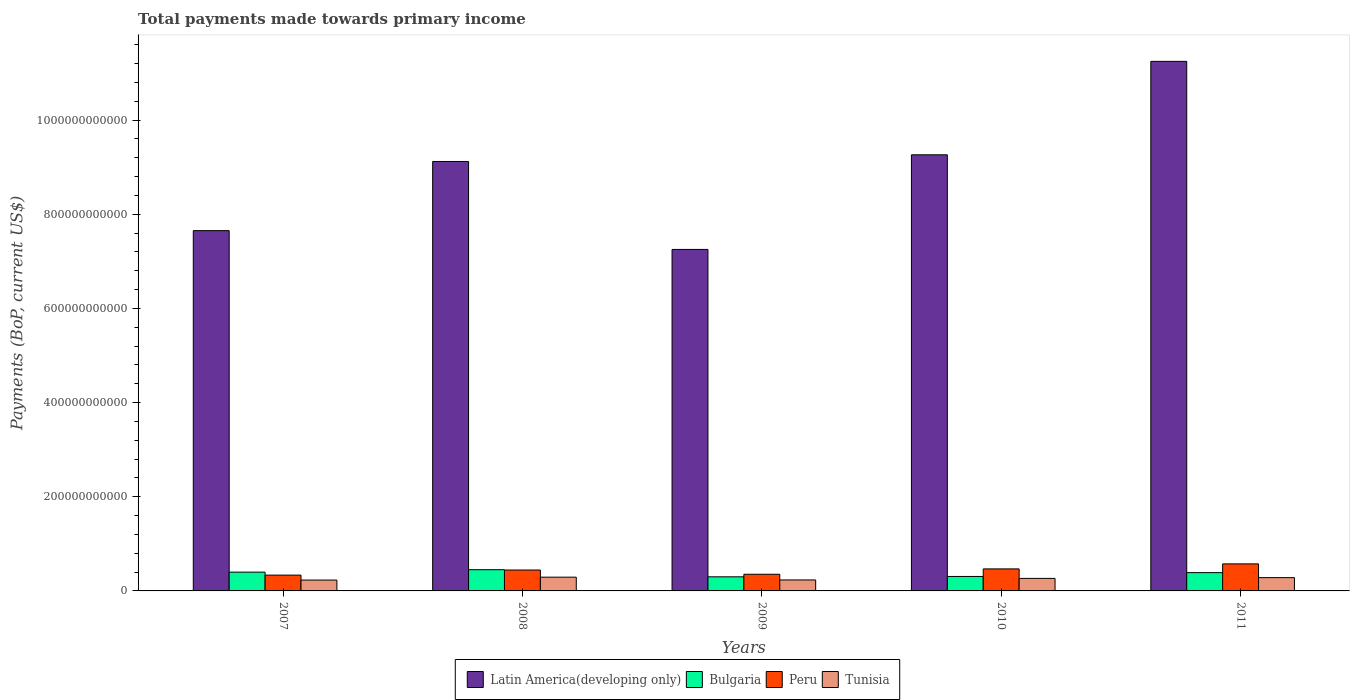How many different coloured bars are there?
Give a very brief answer. 4. Are the number of bars per tick equal to the number of legend labels?
Provide a succinct answer. Yes. Are the number of bars on each tick of the X-axis equal?
Keep it short and to the point. Yes. How many bars are there on the 5th tick from the left?
Ensure brevity in your answer.  4. What is the total payments made towards primary income in Bulgaria in 2010?
Your answer should be compact. 3.07e+1. Across all years, what is the maximum total payments made towards primary income in Bulgaria?
Provide a short and direct response. 4.51e+1. Across all years, what is the minimum total payments made towards primary income in Tunisia?
Your response must be concise. 2.31e+1. What is the total total payments made towards primary income in Bulgaria in the graph?
Offer a terse response. 1.85e+11. What is the difference between the total payments made towards primary income in Bulgaria in 2009 and that in 2010?
Ensure brevity in your answer.  -7.45e+08. What is the difference between the total payments made towards primary income in Latin America(developing only) in 2011 and the total payments made towards primary income in Tunisia in 2010?
Make the answer very short. 1.10e+12. What is the average total payments made towards primary income in Tunisia per year?
Offer a terse response. 2.61e+1. In the year 2010, what is the difference between the total payments made towards primary income in Latin America(developing only) and total payments made towards primary income in Bulgaria?
Give a very brief answer. 8.96e+11. In how many years, is the total payments made towards primary income in Tunisia greater than 840000000000 US$?
Your answer should be compact. 0. What is the ratio of the total payments made towards primary income in Latin America(developing only) in 2007 to that in 2011?
Offer a very short reply. 0.68. Is the difference between the total payments made towards primary income in Latin America(developing only) in 2007 and 2008 greater than the difference between the total payments made towards primary income in Bulgaria in 2007 and 2008?
Make the answer very short. No. What is the difference between the highest and the second highest total payments made towards primary income in Bulgaria?
Your response must be concise. 5.19e+09. What is the difference between the highest and the lowest total payments made towards primary income in Bulgaria?
Your response must be concise. 1.51e+1. Is it the case that in every year, the sum of the total payments made towards primary income in Bulgaria and total payments made towards primary income in Tunisia is greater than the sum of total payments made towards primary income in Peru and total payments made towards primary income in Latin America(developing only)?
Your answer should be compact. No. What does the 1st bar from the left in 2007 represents?
Provide a succinct answer. Latin America(developing only). What does the 1st bar from the right in 2008 represents?
Ensure brevity in your answer.  Tunisia. Is it the case that in every year, the sum of the total payments made towards primary income in Peru and total payments made towards primary income in Latin America(developing only) is greater than the total payments made towards primary income in Tunisia?
Offer a very short reply. Yes. Are all the bars in the graph horizontal?
Your answer should be compact. No. What is the difference between two consecutive major ticks on the Y-axis?
Your response must be concise. 2.00e+11. Are the values on the major ticks of Y-axis written in scientific E-notation?
Ensure brevity in your answer.  No. Does the graph contain grids?
Your answer should be compact. No. Where does the legend appear in the graph?
Your answer should be very brief. Bottom center. What is the title of the graph?
Provide a short and direct response. Total payments made towards primary income. Does "Micronesia" appear as one of the legend labels in the graph?
Your answer should be very brief. No. What is the label or title of the Y-axis?
Keep it short and to the point. Payments (BoP, current US$). What is the Payments (BoP, current US$) in Latin America(developing only) in 2007?
Ensure brevity in your answer.  7.65e+11. What is the Payments (BoP, current US$) in Bulgaria in 2007?
Keep it short and to the point. 3.99e+1. What is the Payments (BoP, current US$) in Peru in 2007?
Provide a succinct answer. 3.36e+1. What is the Payments (BoP, current US$) in Tunisia in 2007?
Your answer should be very brief. 2.31e+1. What is the Payments (BoP, current US$) in Latin America(developing only) in 2008?
Offer a terse response. 9.12e+11. What is the Payments (BoP, current US$) of Bulgaria in 2008?
Ensure brevity in your answer.  4.51e+1. What is the Payments (BoP, current US$) in Peru in 2008?
Your response must be concise. 4.44e+1. What is the Payments (BoP, current US$) of Tunisia in 2008?
Make the answer very short. 2.92e+1. What is the Payments (BoP, current US$) of Latin America(developing only) in 2009?
Offer a very short reply. 7.25e+11. What is the Payments (BoP, current US$) in Bulgaria in 2009?
Offer a very short reply. 3.00e+1. What is the Payments (BoP, current US$) of Peru in 2009?
Offer a terse response. 3.54e+1. What is the Payments (BoP, current US$) in Tunisia in 2009?
Your response must be concise. 2.33e+1. What is the Payments (BoP, current US$) in Latin America(developing only) in 2010?
Offer a terse response. 9.26e+11. What is the Payments (BoP, current US$) of Bulgaria in 2010?
Keep it short and to the point. 3.07e+1. What is the Payments (BoP, current US$) of Peru in 2010?
Keep it short and to the point. 4.68e+1. What is the Payments (BoP, current US$) in Tunisia in 2010?
Provide a succinct answer. 2.66e+1. What is the Payments (BoP, current US$) of Latin America(developing only) in 2011?
Make the answer very short. 1.12e+12. What is the Payments (BoP, current US$) of Bulgaria in 2011?
Your answer should be very brief. 3.88e+1. What is the Payments (BoP, current US$) of Peru in 2011?
Your response must be concise. 5.74e+1. What is the Payments (BoP, current US$) in Tunisia in 2011?
Offer a very short reply. 2.82e+1. Across all years, what is the maximum Payments (BoP, current US$) in Latin America(developing only)?
Give a very brief answer. 1.12e+12. Across all years, what is the maximum Payments (BoP, current US$) in Bulgaria?
Make the answer very short. 4.51e+1. Across all years, what is the maximum Payments (BoP, current US$) in Peru?
Give a very brief answer. 5.74e+1. Across all years, what is the maximum Payments (BoP, current US$) of Tunisia?
Your response must be concise. 2.92e+1. Across all years, what is the minimum Payments (BoP, current US$) of Latin America(developing only)?
Provide a succinct answer. 7.25e+11. Across all years, what is the minimum Payments (BoP, current US$) of Bulgaria?
Offer a terse response. 3.00e+1. Across all years, what is the minimum Payments (BoP, current US$) of Peru?
Ensure brevity in your answer.  3.36e+1. Across all years, what is the minimum Payments (BoP, current US$) in Tunisia?
Your response must be concise. 2.31e+1. What is the total Payments (BoP, current US$) in Latin America(developing only) in the graph?
Offer a very short reply. 4.45e+12. What is the total Payments (BoP, current US$) of Bulgaria in the graph?
Your answer should be very brief. 1.85e+11. What is the total Payments (BoP, current US$) of Peru in the graph?
Offer a very short reply. 2.18e+11. What is the total Payments (BoP, current US$) of Tunisia in the graph?
Make the answer very short. 1.30e+11. What is the difference between the Payments (BoP, current US$) of Latin America(developing only) in 2007 and that in 2008?
Ensure brevity in your answer.  -1.47e+11. What is the difference between the Payments (BoP, current US$) in Bulgaria in 2007 and that in 2008?
Ensure brevity in your answer.  -5.19e+09. What is the difference between the Payments (BoP, current US$) in Peru in 2007 and that in 2008?
Ensure brevity in your answer.  -1.08e+1. What is the difference between the Payments (BoP, current US$) of Tunisia in 2007 and that in 2008?
Give a very brief answer. -6.17e+09. What is the difference between the Payments (BoP, current US$) of Latin America(developing only) in 2007 and that in 2009?
Make the answer very short. 3.99e+1. What is the difference between the Payments (BoP, current US$) in Bulgaria in 2007 and that in 2009?
Give a very brief answer. 9.94e+09. What is the difference between the Payments (BoP, current US$) in Peru in 2007 and that in 2009?
Give a very brief answer. -1.85e+09. What is the difference between the Payments (BoP, current US$) of Tunisia in 2007 and that in 2009?
Offer a terse response. -2.55e+08. What is the difference between the Payments (BoP, current US$) in Latin America(developing only) in 2007 and that in 2010?
Offer a very short reply. -1.61e+11. What is the difference between the Payments (BoP, current US$) of Bulgaria in 2007 and that in 2010?
Offer a terse response. 9.20e+09. What is the difference between the Payments (BoP, current US$) of Peru in 2007 and that in 2010?
Your answer should be very brief. -1.32e+1. What is the difference between the Payments (BoP, current US$) of Tunisia in 2007 and that in 2010?
Keep it short and to the point. -3.53e+09. What is the difference between the Payments (BoP, current US$) in Latin America(developing only) in 2007 and that in 2011?
Offer a terse response. -3.60e+11. What is the difference between the Payments (BoP, current US$) of Bulgaria in 2007 and that in 2011?
Your answer should be compact. 1.07e+09. What is the difference between the Payments (BoP, current US$) of Peru in 2007 and that in 2011?
Ensure brevity in your answer.  -2.39e+1. What is the difference between the Payments (BoP, current US$) of Tunisia in 2007 and that in 2011?
Give a very brief answer. -5.17e+09. What is the difference between the Payments (BoP, current US$) in Latin America(developing only) in 2008 and that in 2009?
Your answer should be compact. 1.87e+11. What is the difference between the Payments (BoP, current US$) of Bulgaria in 2008 and that in 2009?
Offer a terse response. 1.51e+1. What is the difference between the Payments (BoP, current US$) of Peru in 2008 and that in 2009?
Ensure brevity in your answer.  8.99e+09. What is the difference between the Payments (BoP, current US$) in Tunisia in 2008 and that in 2009?
Provide a succinct answer. 5.92e+09. What is the difference between the Payments (BoP, current US$) in Latin America(developing only) in 2008 and that in 2010?
Make the answer very short. -1.42e+1. What is the difference between the Payments (BoP, current US$) in Bulgaria in 2008 and that in 2010?
Your response must be concise. 1.44e+1. What is the difference between the Payments (BoP, current US$) of Peru in 2008 and that in 2010?
Your answer should be compact. -2.39e+09. What is the difference between the Payments (BoP, current US$) in Tunisia in 2008 and that in 2010?
Your answer should be compact. 2.64e+09. What is the difference between the Payments (BoP, current US$) in Latin America(developing only) in 2008 and that in 2011?
Keep it short and to the point. -2.13e+11. What is the difference between the Payments (BoP, current US$) of Bulgaria in 2008 and that in 2011?
Ensure brevity in your answer.  6.26e+09. What is the difference between the Payments (BoP, current US$) in Peru in 2008 and that in 2011?
Ensure brevity in your answer.  -1.30e+1. What is the difference between the Payments (BoP, current US$) in Tunisia in 2008 and that in 2011?
Your answer should be compact. 1.00e+09. What is the difference between the Payments (BoP, current US$) of Latin America(developing only) in 2009 and that in 2010?
Make the answer very short. -2.01e+11. What is the difference between the Payments (BoP, current US$) in Bulgaria in 2009 and that in 2010?
Provide a succinct answer. -7.45e+08. What is the difference between the Payments (BoP, current US$) in Peru in 2009 and that in 2010?
Your answer should be compact. -1.14e+1. What is the difference between the Payments (BoP, current US$) of Tunisia in 2009 and that in 2010?
Offer a terse response. -3.28e+09. What is the difference between the Payments (BoP, current US$) of Latin America(developing only) in 2009 and that in 2011?
Offer a very short reply. -4.00e+11. What is the difference between the Payments (BoP, current US$) of Bulgaria in 2009 and that in 2011?
Ensure brevity in your answer.  -8.87e+09. What is the difference between the Payments (BoP, current US$) of Peru in 2009 and that in 2011?
Your response must be concise. -2.20e+1. What is the difference between the Payments (BoP, current US$) of Tunisia in 2009 and that in 2011?
Give a very brief answer. -4.92e+09. What is the difference between the Payments (BoP, current US$) of Latin America(developing only) in 2010 and that in 2011?
Offer a very short reply. -1.99e+11. What is the difference between the Payments (BoP, current US$) of Bulgaria in 2010 and that in 2011?
Give a very brief answer. -8.13e+09. What is the difference between the Payments (BoP, current US$) of Peru in 2010 and that in 2011?
Provide a short and direct response. -1.06e+1. What is the difference between the Payments (BoP, current US$) of Tunisia in 2010 and that in 2011?
Your response must be concise. -1.64e+09. What is the difference between the Payments (BoP, current US$) of Latin America(developing only) in 2007 and the Payments (BoP, current US$) of Bulgaria in 2008?
Your answer should be very brief. 7.20e+11. What is the difference between the Payments (BoP, current US$) in Latin America(developing only) in 2007 and the Payments (BoP, current US$) in Peru in 2008?
Make the answer very short. 7.21e+11. What is the difference between the Payments (BoP, current US$) in Latin America(developing only) in 2007 and the Payments (BoP, current US$) in Tunisia in 2008?
Provide a short and direct response. 7.36e+11. What is the difference between the Payments (BoP, current US$) of Bulgaria in 2007 and the Payments (BoP, current US$) of Peru in 2008?
Give a very brief answer. -4.50e+09. What is the difference between the Payments (BoP, current US$) in Bulgaria in 2007 and the Payments (BoP, current US$) in Tunisia in 2008?
Offer a very short reply. 1.07e+1. What is the difference between the Payments (BoP, current US$) of Peru in 2007 and the Payments (BoP, current US$) of Tunisia in 2008?
Give a very brief answer. 4.32e+09. What is the difference between the Payments (BoP, current US$) of Latin America(developing only) in 2007 and the Payments (BoP, current US$) of Bulgaria in 2009?
Offer a very short reply. 7.35e+11. What is the difference between the Payments (BoP, current US$) of Latin America(developing only) in 2007 and the Payments (BoP, current US$) of Peru in 2009?
Make the answer very short. 7.30e+11. What is the difference between the Payments (BoP, current US$) in Latin America(developing only) in 2007 and the Payments (BoP, current US$) in Tunisia in 2009?
Give a very brief answer. 7.42e+11. What is the difference between the Payments (BoP, current US$) of Bulgaria in 2007 and the Payments (BoP, current US$) of Peru in 2009?
Provide a succinct answer. 4.50e+09. What is the difference between the Payments (BoP, current US$) in Bulgaria in 2007 and the Payments (BoP, current US$) in Tunisia in 2009?
Make the answer very short. 1.66e+1. What is the difference between the Payments (BoP, current US$) in Peru in 2007 and the Payments (BoP, current US$) in Tunisia in 2009?
Ensure brevity in your answer.  1.02e+1. What is the difference between the Payments (BoP, current US$) in Latin America(developing only) in 2007 and the Payments (BoP, current US$) in Bulgaria in 2010?
Provide a succinct answer. 7.35e+11. What is the difference between the Payments (BoP, current US$) in Latin America(developing only) in 2007 and the Payments (BoP, current US$) in Peru in 2010?
Ensure brevity in your answer.  7.19e+11. What is the difference between the Payments (BoP, current US$) in Latin America(developing only) in 2007 and the Payments (BoP, current US$) in Tunisia in 2010?
Offer a terse response. 7.39e+11. What is the difference between the Payments (BoP, current US$) of Bulgaria in 2007 and the Payments (BoP, current US$) of Peru in 2010?
Give a very brief answer. -6.89e+09. What is the difference between the Payments (BoP, current US$) in Bulgaria in 2007 and the Payments (BoP, current US$) in Tunisia in 2010?
Give a very brief answer. 1.33e+1. What is the difference between the Payments (BoP, current US$) of Peru in 2007 and the Payments (BoP, current US$) of Tunisia in 2010?
Make the answer very short. 6.96e+09. What is the difference between the Payments (BoP, current US$) of Latin America(developing only) in 2007 and the Payments (BoP, current US$) of Bulgaria in 2011?
Provide a succinct answer. 7.26e+11. What is the difference between the Payments (BoP, current US$) in Latin America(developing only) in 2007 and the Payments (BoP, current US$) in Peru in 2011?
Provide a succinct answer. 7.08e+11. What is the difference between the Payments (BoP, current US$) of Latin America(developing only) in 2007 and the Payments (BoP, current US$) of Tunisia in 2011?
Keep it short and to the point. 7.37e+11. What is the difference between the Payments (BoP, current US$) in Bulgaria in 2007 and the Payments (BoP, current US$) in Peru in 2011?
Offer a very short reply. -1.75e+1. What is the difference between the Payments (BoP, current US$) in Bulgaria in 2007 and the Payments (BoP, current US$) in Tunisia in 2011?
Your response must be concise. 1.17e+1. What is the difference between the Payments (BoP, current US$) of Peru in 2007 and the Payments (BoP, current US$) of Tunisia in 2011?
Provide a short and direct response. 5.32e+09. What is the difference between the Payments (BoP, current US$) of Latin America(developing only) in 2008 and the Payments (BoP, current US$) of Bulgaria in 2009?
Ensure brevity in your answer.  8.82e+11. What is the difference between the Payments (BoP, current US$) of Latin America(developing only) in 2008 and the Payments (BoP, current US$) of Peru in 2009?
Your answer should be compact. 8.77e+11. What is the difference between the Payments (BoP, current US$) in Latin America(developing only) in 2008 and the Payments (BoP, current US$) in Tunisia in 2009?
Provide a short and direct response. 8.89e+11. What is the difference between the Payments (BoP, current US$) in Bulgaria in 2008 and the Payments (BoP, current US$) in Peru in 2009?
Provide a succinct answer. 9.68e+09. What is the difference between the Payments (BoP, current US$) of Bulgaria in 2008 and the Payments (BoP, current US$) of Tunisia in 2009?
Give a very brief answer. 2.18e+1. What is the difference between the Payments (BoP, current US$) in Peru in 2008 and the Payments (BoP, current US$) in Tunisia in 2009?
Offer a terse response. 2.11e+1. What is the difference between the Payments (BoP, current US$) in Latin America(developing only) in 2008 and the Payments (BoP, current US$) in Bulgaria in 2010?
Make the answer very short. 8.82e+11. What is the difference between the Payments (BoP, current US$) in Latin America(developing only) in 2008 and the Payments (BoP, current US$) in Peru in 2010?
Offer a very short reply. 8.65e+11. What is the difference between the Payments (BoP, current US$) of Latin America(developing only) in 2008 and the Payments (BoP, current US$) of Tunisia in 2010?
Offer a very short reply. 8.86e+11. What is the difference between the Payments (BoP, current US$) of Bulgaria in 2008 and the Payments (BoP, current US$) of Peru in 2010?
Ensure brevity in your answer.  -1.70e+09. What is the difference between the Payments (BoP, current US$) of Bulgaria in 2008 and the Payments (BoP, current US$) of Tunisia in 2010?
Provide a succinct answer. 1.85e+1. What is the difference between the Payments (BoP, current US$) of Peru in 2008 and the Payments (BoP, current US$) of Tunisia in 2010?
Offer a very short reply. 1.78e+1. What is the difference between the Payments (BoP, current US$) of Latin America(developing only) in 2008 and the Payments (BoP, current US$) of Bulgaria in 2011?
Your answer should be very brief. 8.73e+11. What is the difference between the Payments (BoP, current US$) of Latin America(developing only) in 2008 and the Payments (BoP, current US$) of Peru in 2011?
Your response must be concise. 8.55e+11. What is the difference between the Payments (BoP, current US$) in Latin America(developing only) in 2008 and the Payments (BoP, current US$) in Tunisia in 2011?
Your answer should be compact. 8.84e+11. What is the difference between the Payments (BoP, current US$) in Bulgaria in 2008 and the Payments (BoP, current US$) in Peru in 2011?
Offer a very short reply. -1.23e+1. What is the difference between the Payments (BoP, current US$) in Bulgaria in 2008 and the Payments (BoP, current US$) in Tunisia in 2011?
Provide a succinct answer. 1.69e+1. What is the difference between the Payments (BoP, current US$) of Peru in 2008 and the Payments (BoP, current US$) of Tunisia in 2011?
Give a very brief answer. 1.62e+1. What is the difference between the Payments (BoP, current US$) of Latin America(developing only) in 2009 and the Payments (BoP, current US$) of Bulgaria in 2010?
Provide a short and direct response. 6.95e+11. What is the difference between the Payments (BoP, current US$) in Latin America(developing only) in 2009 and the Payments (BoP, current US$) in Peru in 2010?
Offer a terse response. 6.79e+11. What is the difference between the Payments (BoP, current US$) in Latin America(developing only) in 2009 and the Payments (BoP, current US$) in Tunisia in 2010?
Your answer should be compact. 6.99e+11. What is the difference between the Payments (BoP, current US$) of Bulgaria in 2009 and the Payments (BoP, current US$) of Peru in 2010?
Ensure brevity in your answer.  -1.68e+1. What is the difference between the Payments (BoP, current US$) of Bulgaria in 2009 and the Payments (BoP, current US$) of Tunisia in 2010?
Offer a very short reply. 3.37e+09. What is the difference between the Payments (BoP, current US$) in Peru in 2009 and the Payments (BoP, current US$) in Tunisia in 2010?
Make the answer very short. 8.82e+09. What is the difference between the Payments (BoP, current US$) in Latin America(developing only) in 2009 and the Payments (BoP, current US$) in Bulgaria in 2011?
Your response must be concise. 6.87e+11. What is the difference between the Payments (BoP, current US$) in Latin America(developing only) in 2009 and the Payments (BoP, current US$) in Peru in 2011?
Offer a very short reply. 6.68e+11. What is the difference between the Payments (BoP, current US$) in Latin America(developing only) in 2009 and the Payments (BoP, current US$) in Tunisia in 2011?
Your answer should be compact. 6.97e+11. What is the difference between the Payments (BoP, current US$) of Bulgaria in 2009 and the Payments (BoP, current US$) of Peru in 2011?
Keep it short and to the point. -2.75e+1. What is the difference between the Payments (BoP, current US$) in Bulgaria in 2009 and the Payments (BoP, current US$) in Tunisia in 2011?
Ensure brevity in your answer.  1.73e+09. What is the difference between the Payments (BoP, current US$) in Peru in 2009 and the Payments (BoP, current US$) in Tunisia in 2011?
Keep it short and to the point. 7.18e+09. What is the difference between the Payments (BoP, current US$) in Latin America(developing only) in 2010 and the Payments (BoP, current US$) in Bulgaria in 2011?
Your answer should be very brief. 8.88e+11. What is the difference between the Payments (BoP, current US$) in Latin America(developing only) in 2010 and the Payments (BoP, current US$) in Peru in 2011?
Give a very brief answer. 8.69e+11. What is the difference between the Payments (BoP, current US$) in Latin America(developing only) in 2010 and the Payments (BoP, current US$) in Tunisia in 2011?
Your answer should be compact. 8.98e+11. What is the difference between the Payments (BoP, current US$) in Bulgaria in 2010 and the Payments (BoP, current US$) in Peru in 2011?
Your answer should be compact. -2.67e+1. What is the difference between the Payments (BoP, current US$) in Bulgaria in 2010 and the Payments (BoP, current US$) in Tunisia in 2011?
Your response must be concise. 2.48e+09. What is the difference between the Payments (BoP, current US$) of Peru in 2010 and the Payments (BoP, current US$) of Tunisia in 2011?
Provide a succinct answer. 1.86e+1. What is the average Payments (BoP, current US$) in Latin America(developing only) per year?
Offer a very short reply. 8.91e+11. What is the average Payments (BoP, current US$) of Bulgaria per year?
Offer a very short reply. 3.69e+1. What is the average Payments (BoP, current US$) in Peru per year?
Provide a succinct answer. 4.35e+1. What is the average Payments (BoP, current US$) of Tunisia per year?
Provide a short and direct response. 2.61e+1. In the year 2007, what is the difference between the Payments (BoP, current US$) of Latin America(developing only) and Payments (BoP, current US$) of Bulgaria?
Give a very brief answer. 7.25e+11. In the year 2007, what is the difference between the Payments (BoP, current US$) of Latin America(developing only) and Payments (BoP, current US$) of Peru?
Give a very brief answer. 7.32e+11. In the year 2007, what is the difference between the Payments (BoP, current US$) in Latin America(developing only) and Payments (BoP, current US$) in Tunisia?
Make the answer very short. 7.42e+11. In the year 2007, what is the difference between the Payments (BoP, current US$) of Bulgaria and Payments (BoP, current US$) of Peru?
Ensure brevity in your answer.  6.35e+09. In the year 2007, what is the difference between the Payments (BoP, current US$) in Bulgaria and Payments (BoP, current US$) in Tunisia?
Your answer should be compact. 1.68e+1. In the year 2007, what is the difference between the Payments (BoP, current US$) in Peru and Payments (BoP, current US$) in Tunisia?
Provide a succinct answer. 1.05e+1. In the year 2008, what is the difference between the Payments (BoP, current US$) of Latin America(developing only) and Payments (BoP, current US$) of Bulgaria?
Make the answer very short. 8.67e+11. In the year 2008, what is the difference between the Payments (BoP, current US$) in Latin America(developing only) and Payments (BoP, current US$) in Peru?
Ensure brevity in your answer.  8.68e+11. In the year 2008, what is the difference between the Payments (BoP, current US$) in Latin America(developing only) and Payments (BoP, current US$) in Tunisia?
Offer a terse response. 8.83e+11. In the year 2008, what is the difference between the Payments (BoP, current US$) in Bulgaria and Payments (BoP, current US$) in Peru?
Ensure brevity in your answer.  6.92e+08. In the year 2008, what is the difference between the Payments (BoP, current US$) of Bulgaria and Payments (BoP, current US$) of Tunisia?
Offer a terse response. 1.59e+1. In the year 2008, what is the difference between the Payments (BoP, current US$) of Peru and Payments (BoP, current US$) of Tunisia?
Provide a short and direct response. 1.52e+1. In the year 2009, what is the difference between the Payments (BoP, current US$) in Latin America(developing only) and Payments (BoP, current US$) in Bulgaria?
Keep it short and to the point. 6.95e+11. In the year 2009, what is the difference between the Payments (BoP, current US$) in Latin America(developing only) and Payments (BoP, current US$) in Peru?
Offer a terse response. 6.90e+11. In the year 2009, what is the difference between the Payments (BoP, current US$) of Latin America(developing only) and Payments (BoP, current US$) of Tunisia?
Your answer should be very brief. 7.02e+11. In the year 2009, what is the difference between the Payments (BoP, current US$) of Bulgaria and Payments (BoP, current US$) of Peru?
Give a very brief answer. -5.45e+09. In the year 2009, what is the difference between the Payments (BoP, current US$) in Bulgaria and Payments (BoP, current US$) in Tunisia?
Your answer should be very brief. 6.65e+09. In the year 2009, what is the difference between the Payments (BoP, current US$) in Peru and Payments (BoP, current US$) in Tunisia?
Give a very brief answer. 1.21e+1. In the year 2010, what is the difference between the Payments (BoP, current US$) in Latin America(developing only) and Payments (BoP, current US$) in Bulgaria?
Your response must be concise. 8.96e+11. In the year 2010, what is the difference between the Payments (BoP, current US$) in Latin America(developing only) and Payments (BoP, current US$) in Peru?
Keep it short and to the point. 8.80e+11. In the year 2010, what is the difference between the Payments (BoP, current US$) in Latin America(developing only) and Payments (BoP, current US$) in Tunisia?
Ensure brevity in your answer.  9.00e+11. In the year 2010, what is the difference between the Payments (BoP, current US$) of Bulgaria and Payments (BoP, current US$) of Peru?
Your answer should be very brief. -1.61e+1. In the year 2010, what is the difference between the Payments (BoP, current US$) of Bulgaria and Payments (BoP, current US$) of Tunisia?
Offer a very short reply. 4.12e+09. In the year 2010, what is the difference between the Payments (BoP, current US$) of Peru and Payments (BoP, current US$) of Tunisia?
Offer a terse response. 2.02e+1. In the year 2011, what is the difference between the Payments (BoP, current US$) in Latin America(developing only) and Payments (BoP, current US$) in Bulgaria?
Offer a terse response. 1.09e+12. In the year 2011, what is the difference between the Payments (BoP, current US$) of Latin America(developing only) and Payments (BoP, current US$) of Peru?
Provide a short and direct response. 1.07e+12. In the year 2011, what is the difference between the Payments (BoP, current US$) in Latin America(developing only) and Payments (BoP, current US$) in Tunisia?
Offer a very short reply. 1.10e+12. In the year 2011, what is the difference between the Payments (BoP, current US$) in Bulgaria and Payments (BoP, current US$) in Peru?
Provide a succinct answer. -1.86e+1. In the year 2011, what is the difference between the Payments (BoP, current US$) of Bulgaria and Payments (BoP, current US$) of Tunisia?
Your answer should be very brief. 1.06e+1. In the year 2011, what is the difference between the Payments (BoP, current US$) in Peru and Payments (BoP, current US$) in Tunisia?
Your answer should be very brief. 2.92e+1. What is the ratio of the Payments (BoP, current US$) in Latin America(developing only) in 2007 to that in 2008?
Offer a very short reply. 0.84. What is the ratio of the Payments (BoP, current US$) of Bulgaria in 2007 to that in 2008?
Your answer should be compact. 0.89. What is the ratio of the Payments (BoP, current US$) of Peru in 2007 to that in 2008?
Give a very brief answer. 0.76. What is the ratio of the Payments (BoP, current US$) in Tunisia in 2007 to that in 2008?
Ensure brevity in your answer.  0.79. What is the ratio of the Payments (BoP, current US$) of Latin America(developing only) in 2007 to that in 2009?
Provide a succinct answer. 1.05. What is the ratio of the Payments (BoP, current US$) of Bulgaria in 2007 to that in 2009?
Your response must be concise. 1.33. What is the ratio of the Payments (BoP, current US$) in Peru in 2007 to that in 2009?
Offer a very short reply. 0.95. What is the ratio of the Payments (BoP, current US$) in Tunisia in 2007 to that in 2009?
Offer a terse response. 0.99. What is the ratio of the Payments (BoP, current US$) in Latin America(developing only) in 2007 to that in 2010?
Your response must be concise. 0.83. What is the ratio of the Payments (BoP, current US$) in Bulgaria in 2007 to that in 2010?
Give a very brief answer. 1.3. What is the ratio of the Payments (BoP, current US$) of Peru in 2007 to that in 2010?
Make the answer very short. 0.72. What is the ratio of the Payments (BoP, current US$) of Tunisia in 2007 to that in 2010?
Provide a short and direct response. 0.87. What is the ratio of the Payments (BoP, current US$) of Latin America(developing only) in 2007 to that in 2011?
Your answer should be compact. 0.68. What is the ratio of the Payments (BoP, current US$) in Bulgaria in 2007 to that in 2011?
Offer a terse response. 1.03. What is the ratio of the Payments (BoP, current US$) of Peru in 2007 to that in 2011?
Give a very brief answer. 0.58. What is the ratio of the Payments (BoP, current US$) of Tunisia in 2007 to that in 2011?
Provide a succinct answer. 0.82. What is the ratio of the Payments (BoP, current US$) of Latin America(developing only) in 2008 to that in 2009?
Your answer should be compact. 1.26. What is the ratio of the Payments (BoP, current US$) of Bulgaria in 2008 to that in 2009?
Provide a short and direct response. 1.5. What is the ratio of the Payments (BoP, current US$) in Peru in 2008 to that in 2009?
Offer a very short reply. 1.25. What is the ratio of the Payments (BoP, current US$) of Tunisia in 2008 to that in 2009?
Make the answer very short. 1.25. What is the ratio of the Payments (BoP, current US$) in Latin America(developing only) in 2008 to that in 2010?
Provide a short and direct response. 0.98. What is the ratio of the Payments (BoP, current US$) of Bulgaria in 2008 to that in 2010?
Make the answer very short. 1.47. What is the ratio of the Payments (BoP, current US$) of Peru in 2008 to that in 2010?
Make the answer very short. 0.95. What is the ratio of the Payments (BoP, current US$) of Tunisia in 2008 to that in 2010?
Make the answer very short. 1.1. What is the ratio of the Payments (BoP, current US$) of Latin America(developing only) in 2008 to that in 2011?
Offer a very short reply. 0.81. What is the ratio of the Payments (BoP, current US$) in Bulgaria in 2008 to that in 2011?
Your response must be concise. 1.16. What is the ratio of the Payments (BoP, current US$) in Peru in 2008 to that in 2011?
Your answer should be very brief. 0.77. What is the ratio of the Payments (BoP, current US$) in Tunisia in 2008 to that in 2011?
Your response must be concise. 1.04. What is the ratio of the Payments (BoP, current US$) of Latin America(developing only) in 2009 to that in 2010?
Make the answer very short. 0.78. What is the ratio of the Payments (BoP, current US$) of Bulgaria in 2009 to that in 2010?
Ensure brevity in your answer.  0.98. What is the ratio of the Payments (BoP, current US$) of Peru in 2009 to that in 2010?
Give a very brief answer. 0.76. What is the ratio of the Payments (BoP, current US$) in Tunisia in 2009 to that in 2010?
Keep it short and to the point. 0.88. What is the ratio of the Payments (BoP, current US$) of Latin America(developing only) in 2009 to that in 2011?
Your answer should be very brief. 0.64. What is the ratio of the Payments (BoP, current US$) of Bulgaria in 2009 to that in 2011?
Your answer should be very brief. 0.77. What is the ratio of the Payments (BoP, current US$) of Peru in 2009 to that in 2011?
Your answer should be compact. 0.62. What is the ratio of the Payments (BoP, current US$) in Tunisia in 2009 to that in 2011?
Your response must be concise. 0.83. What is the ratio of the Payments (BoP, current US$) of Latin America(developing only) in 2010 to that in 2011?
Your response must be concise. 0.82. What is the ratio of the Payments (BoP, current US$) of Bulgaria in 2010 to that in 2011?
Provide a short and direct response. 0.79. What is the ratio of the Payments (BoP, current US$) in Peru in 2010 to that in 2011?
Give a very brief answer. 0.81. What is the ratio of the Payments (BoP, current US$) in Tunisia in 2010 to that in 2011?
Provide a short and direct response. 0.94. What is the difference between the highest and the second highest Payments (BoP, current US$) in Latin America(developing only)?
Ensure brevity in your answer.  1.99e+11. What is the difference between the highest and the second highest Payments (BoP, current US$) of Bulgaria?
Make the answer very short. 5.19e+09. What is the difference between the highest and the second highest Payments (BoP, current US$) of Peru?
Ensure brevity in your answer.  1.06e+1. What is the difference between the highest and the second highest Payments (BoP, current US$) of Tunisia?
Offer a very short reply. 1.00e+09. What is the difference between the highest and the lowest Payments (BoP, current US$) of Latin America(developing only)?
Offer a terse response. 4.00e+11. What is the difference between the highest and the lowest Payments (BoP, current US$) in Bulgaria?
Ensure brevity in your answer.  1.51e+1. What is the difference between the highest and the lowest Payments (BoP, current US$) in Peru?
Your response must be concise. 2.39e+1. What is the difference between the highest and the lowest Payments (BoP, current US$) in Tunisia?
Keep it short and to the point. 6.17e+09. 